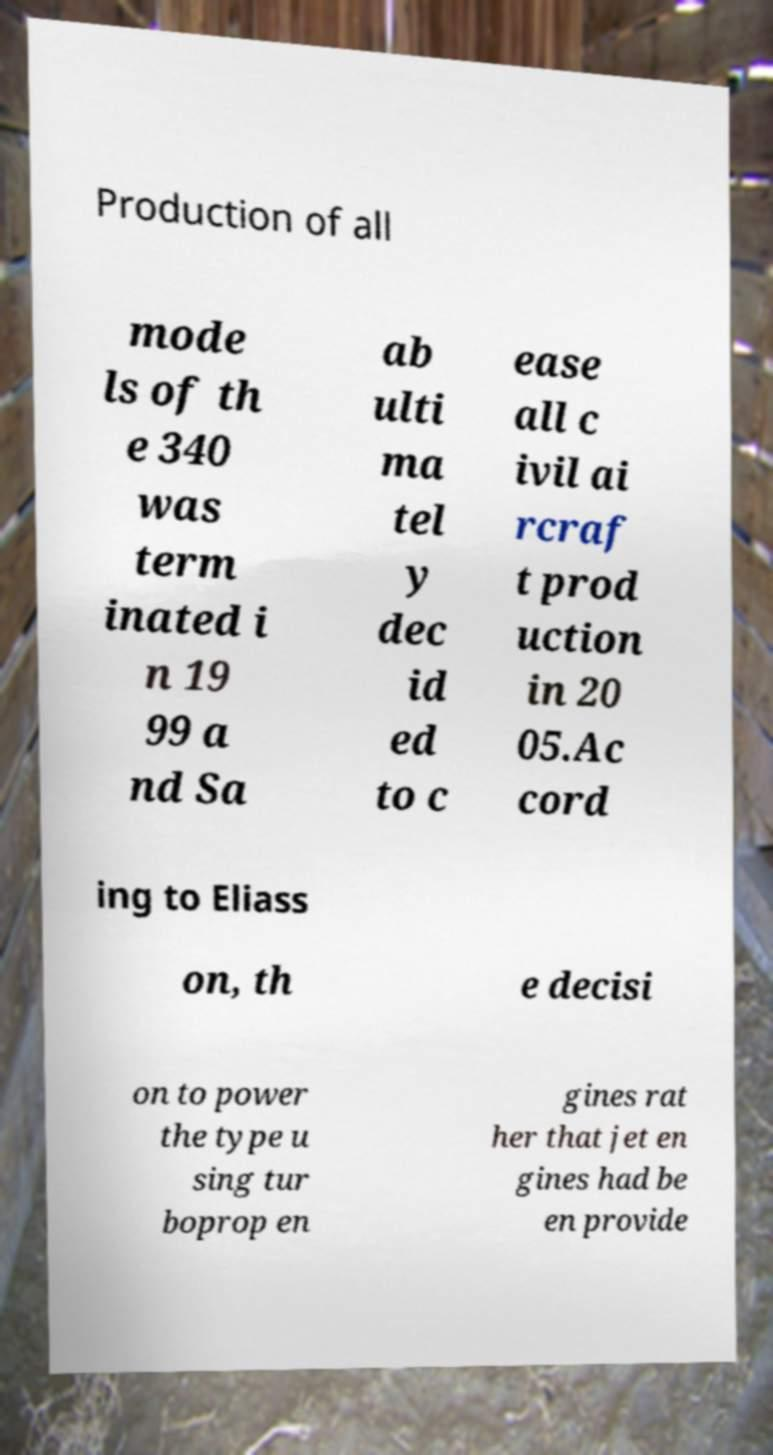Could you assist in decoding the text presented in this image and type it out clearly? Production of all mode ls of th e 340 was term inated i n 19 99 a nd Sa ab ulti ma tel y dec id ed to c ease all c ivil ai rcraf t prod uction in 20 05.Ac cord ing to Eliass on, th e decisi on to power the type u sing tur boprop en gines rat her that jet en gines had be en provide 